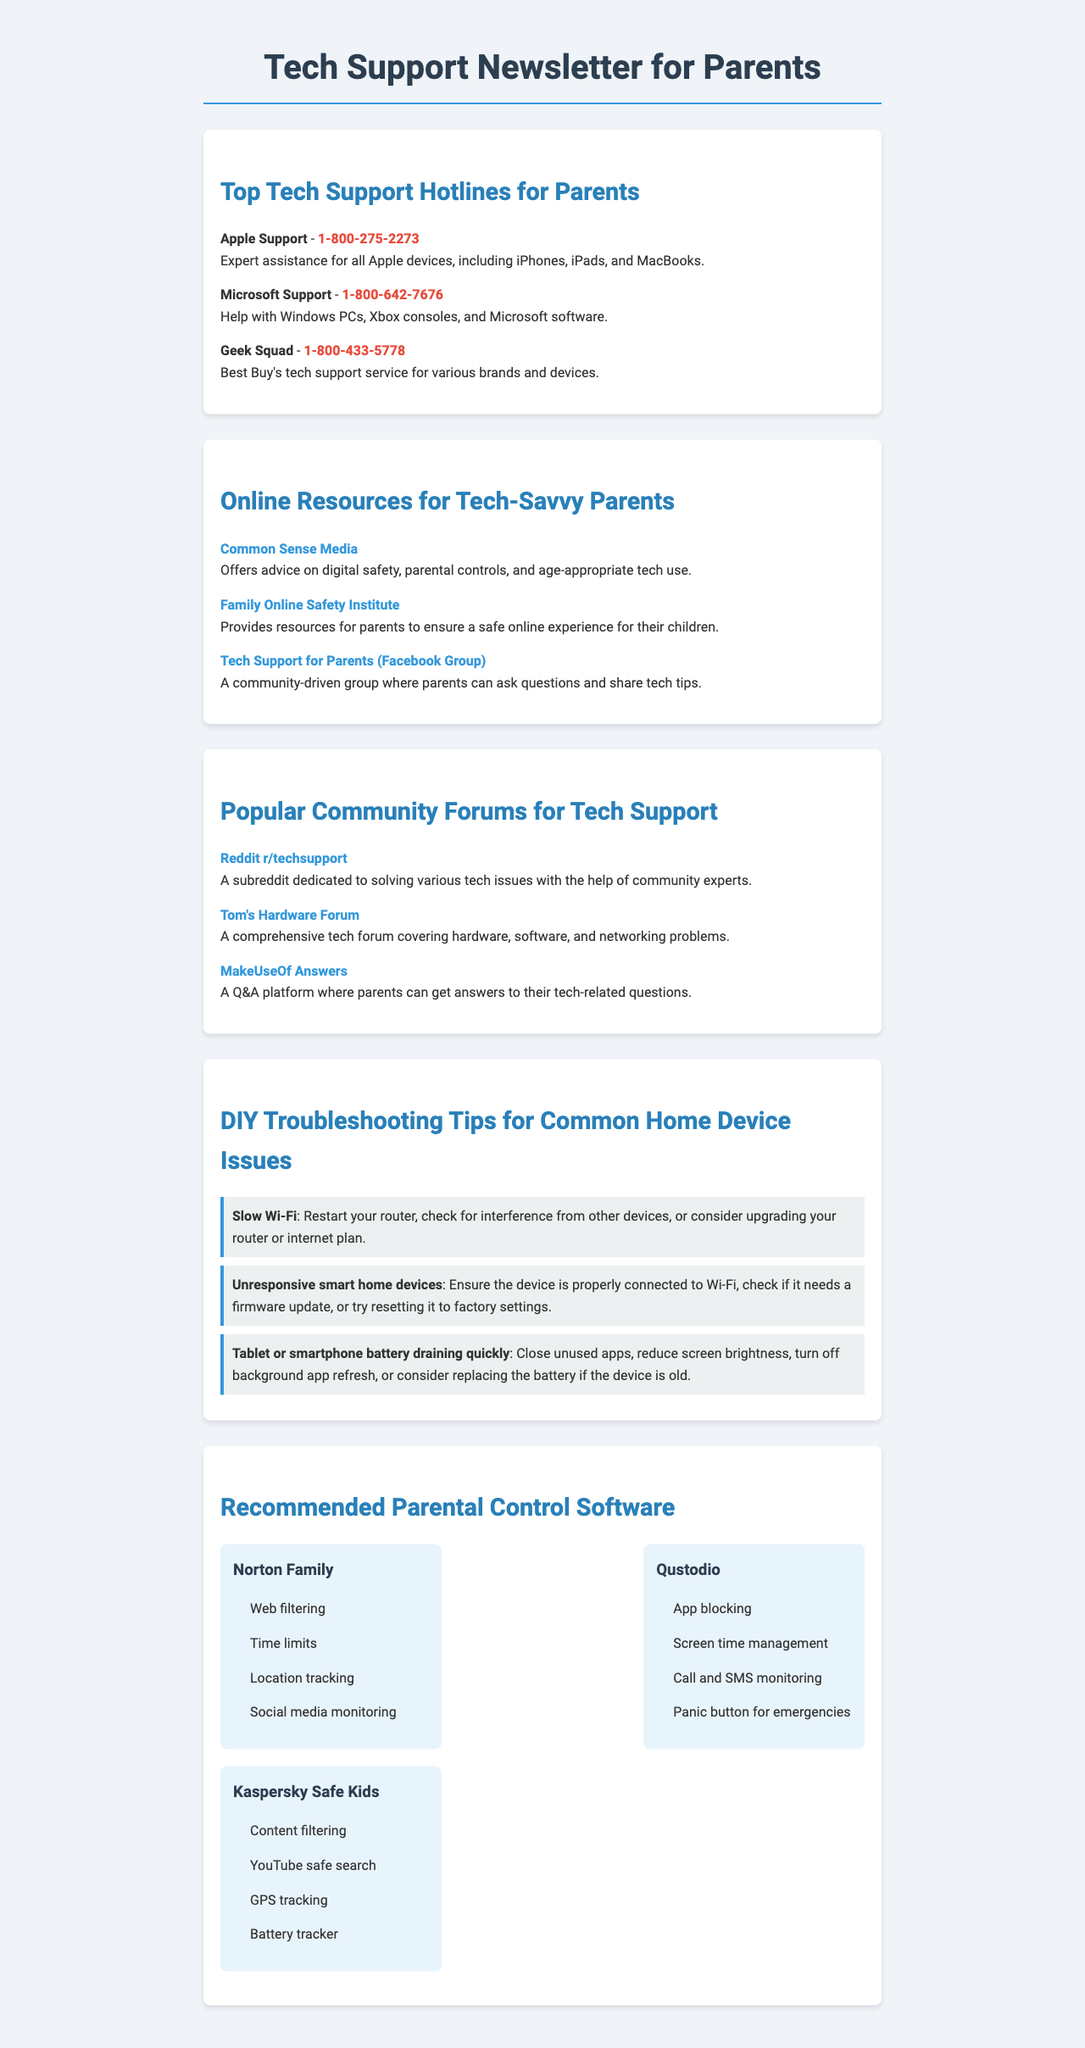What is the phone number for Apple Support? The phone number for Apple Support is listed in the document under "Top Tech Support Hotlines for Parents."
Answer: 1-800-275-2273 What type of assistance does Geek Squad provide? Geek Squad offers tech support for various brands and devices, as mentioned in their description.
Answer: Various brands and devices What is the URL for Common Sense Media? The URL for Common Sense Media is provided in the section regarding online resources for parents.
Answer: https://www.commonsensemedia.org/ Which community forum focuses on tech issues? The document lists several community forums, and one specifically dedicated to tech issues is mentioned.
Answer: Reddit r/techsupport What is one problem addressed in the DIY Troubleshooting Tips section? The document lists several common problems with solutions in the DIY Troubleshooting Tips section.
Answer: Slow Wi-Fi How many features does Norton Family provide? The document enumerates the features of various parental control software, including Norton Family, which is specified.
Answer: Four Which group is mentioned as a community-driven tech support resource? The document lists a Facebook group that allows parents to ask questions and share tech tips.
Answer: Tech Support for Parents What is the contact number for Microsoft Support? The Microsoft Support contact number is included in the directory of tech support hotlines.
Answer: 1-800-642-7676 What are parents advised to do for unresponsive smart home devices? The document provides a solution in the DIY Troubleshooting Tips section for this specific issue.
Answer: Ensure proper connection to Wi-Fi 